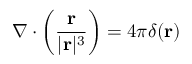<formula> <loc_0><loc_0><loc_500><loc_500>\nabla \cdot \left ( { \frac { r } { | r | ^ { 3 } } } \right ) = 4 \pi \delta ( r )</formula> 